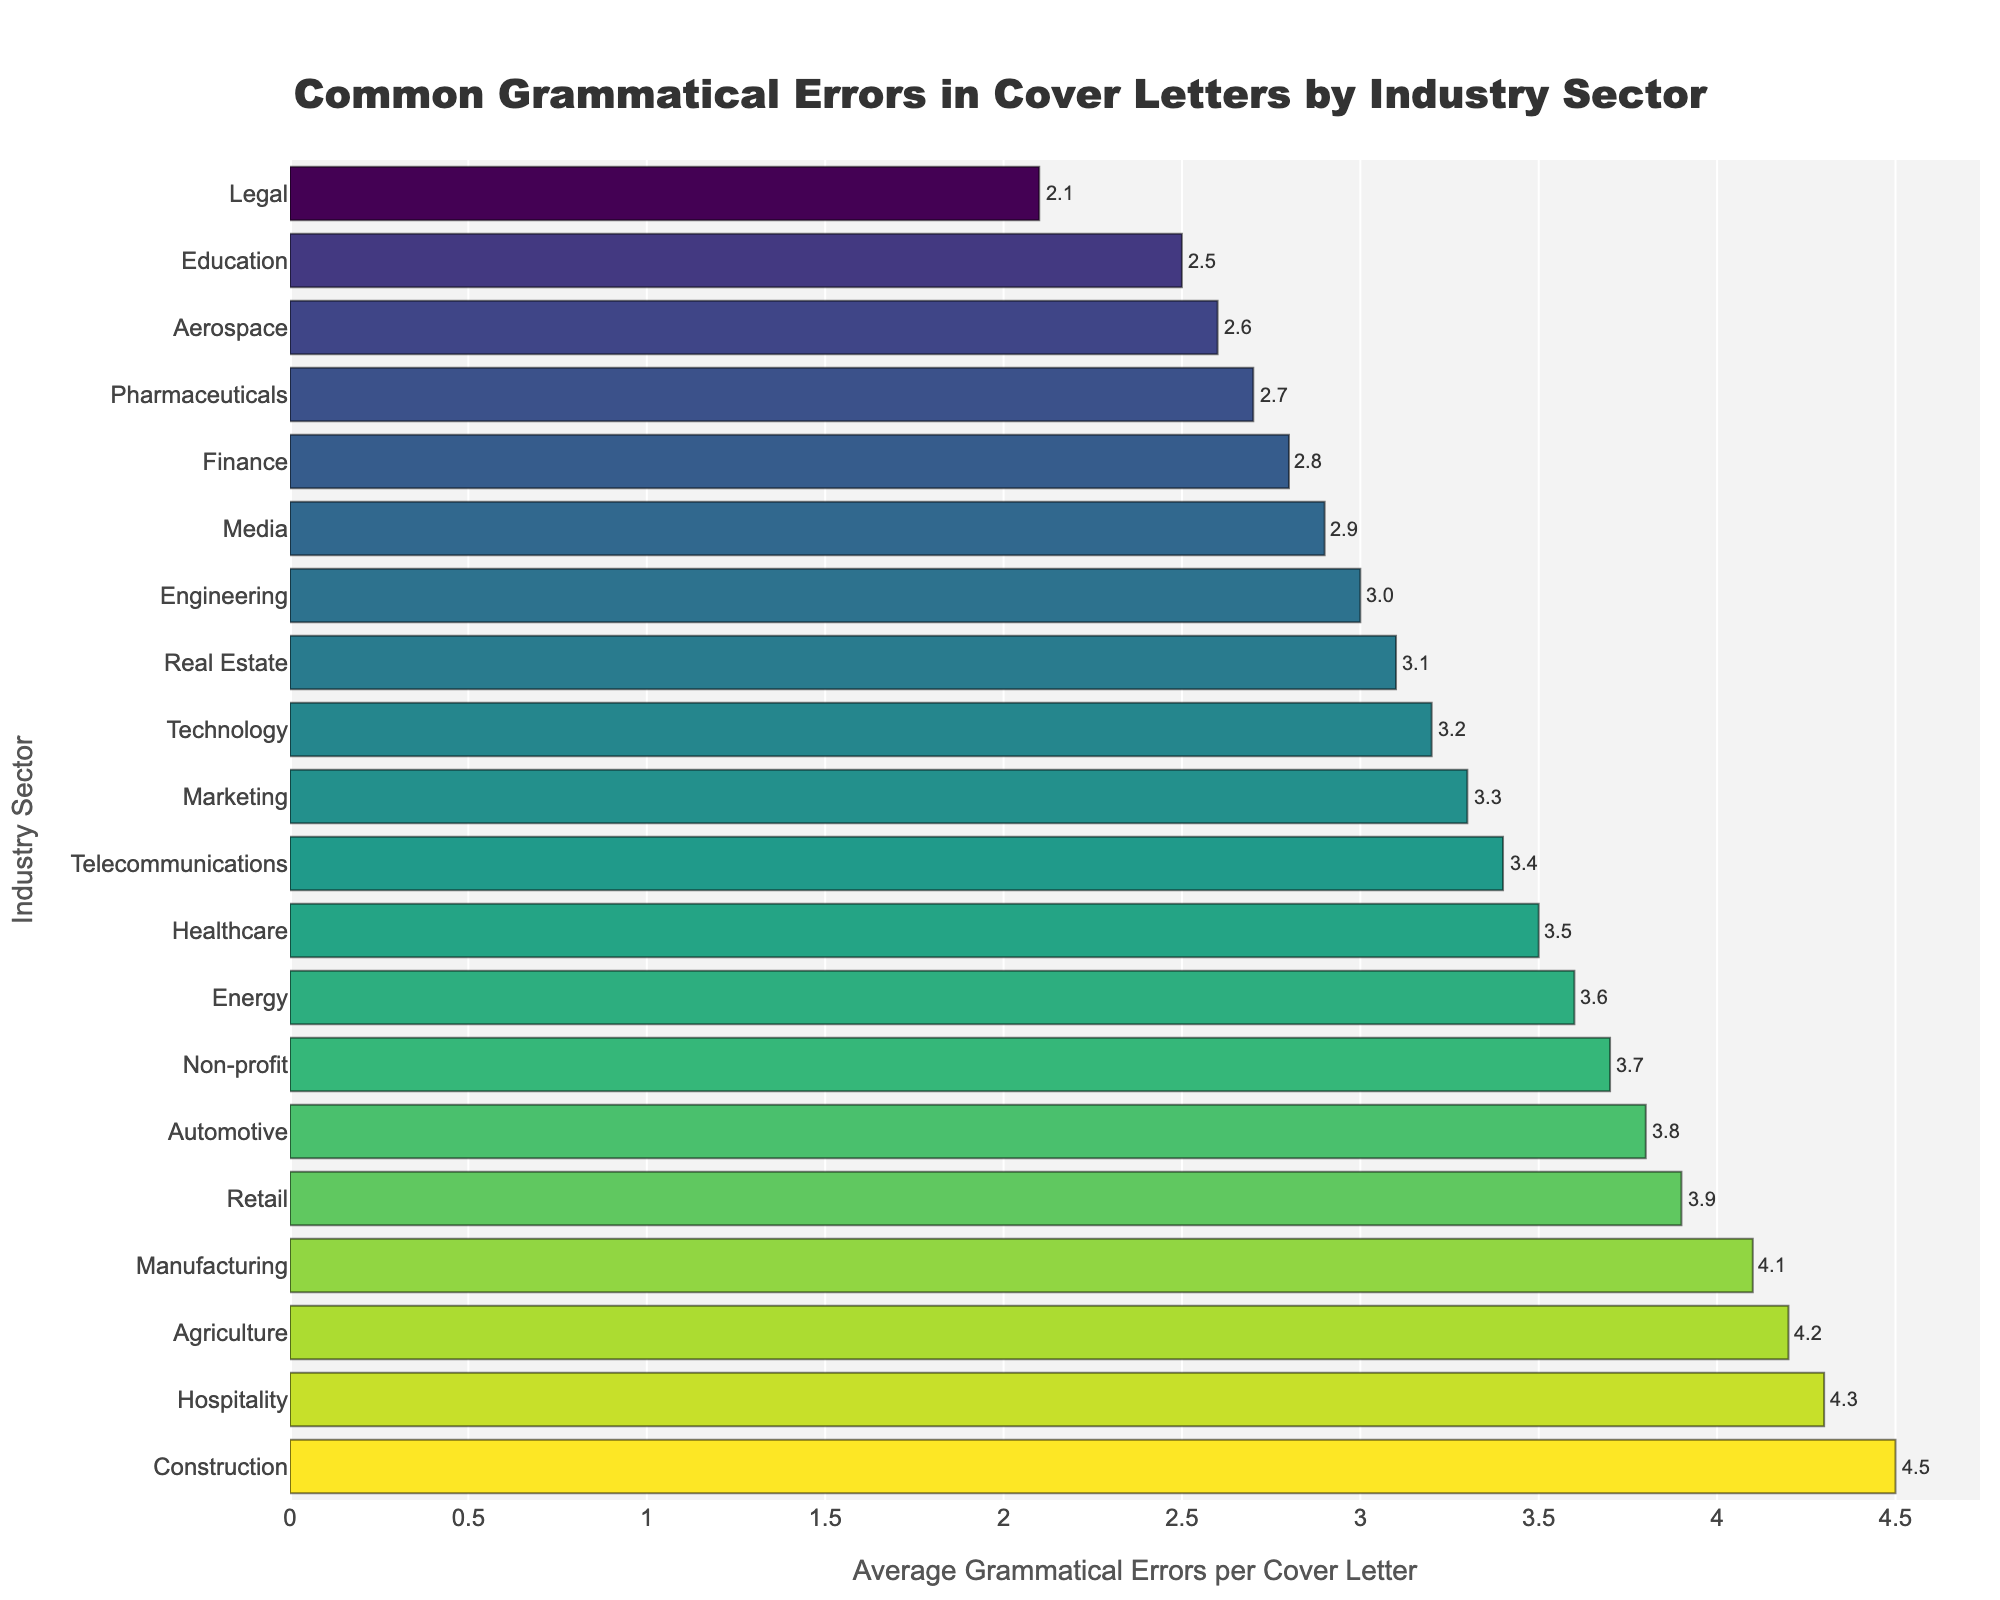What industry sector has the highest average grammatical errors per cover letter? The industry sector with the highest average grammatical errors per cover letter can be found by looking for the bar that extends the farthest to the right. In this case, it is "Construction" with an average of 4.5 errors per cover letter.
Answer: Construction What industry sector has the lowest average grammatical errors per cover letter? The industry sector with the lowest average grammatical errors per cover letter can be found by looking for the bar that extends the least to the right. In this case, it is "Legal" with an average of 2.1 errors per cover letter.
Answer: Legal Which industry sectors have an average grammatical error rate above 4? To find the industry sectors with an average grammatical error rate above 4, look for bars that extend beyond the 4 mark on the x-axis. These sectors are "Construction," "Hospitality," "Agriculture," and "Manufacturing."
Answer: Construction, Hospitality, Agriculture, Manufacturing How many industry sectors have an average grammatical error rate below 3? Count the number of bars that extend below the 3 mark on the x-axis. The bars for "Legal," "Aerospace," "Pharmaceuticals," "Education," "Finance," and "Media" are all below 3.
Answer: 6 What is the average grammatical error rate for Technology, Marketing, and Real Estate combined? To find the combined average error rate for Technology, Marketing, and Real Estate, first sum their individual error rates: 3.2 (Technology) + 3.3 (Marketing) + 3.1 (Real Estate) = 9.6. Then, divide by the number of industries: 9.6 / 3 = 3.2.
Answer: 3.2 Which two industry sectors have the closest average grammatical error rates, and what are those rates? Look for bars that are closest in length. The bars for "Finance" (2.8) and "Media" (2.9) are closest to each other.
Answer: Finance and Media; 2.8 and 2.9 What is the difference in average grammatical errors per cover letter between Healthcare and Education sectors? Subtract the number of errors in the Education sector from the Healthcare sector: 3.5 (Healthcare) - 2.5 (Education) = 1.0.
Answer: 1.0 Which industries fall into the middle error rate range between 3.2 and 3.5? Identify the bars that fall within this specific range by looking at the x-axis values. The industries in this range are "Technology" (3.2), "Marketing" (3.3), "Telecommunications" (3.4), and "Healthcare" (3.5).
Answer: Technology, Marketing, Telecommunications, Healthcare What is the sum of the average grammatical errors for the sectors with the top three highest error rates? Identify the top three sectors: "Construction" (4.5), "Hospitality" (4.3), and "Agriculture" (4.2). Add these values: 4.5 + 4.3 + 4.2 = 13.0.
Answer: 13.0 